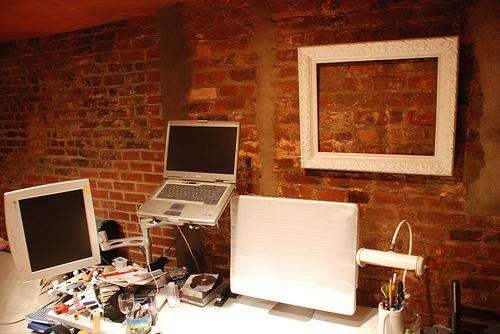Question: how many computer screens are in the picture?
Choices:
A. Four.
B. Two.
C. Five.
D. Three.
Answer with the letter. Answer: D Question: what is visible in the picture frame?
Choices:
A. The photo.
B. The light reflected.
C. The wall.
D. People.
Answer with the letter. Answer: C Question: where is the laptop?
Choices:
A. Between the two screens.
B. On the bed.
C. On the sofa.
D. On her lap.
Answer with the letter. Answer: A Question: what material is the wall made of?
Choices:
A. Dry wall plaster.
B. Bricks.
C. Stucco.
D. Wood.
Answer with the letter. Answer: B Question: what shape is the picture frame?
Choices:
A. Circle.
B. Square.
C. Triangle.
D. Rectangle.
Answer with the letter. Answer: D Question: what shape is the desk light above the pencil cup?
Choices:
A. Round.
B. Square.
C. Oval.
D. Cylinder.
Answer with the letter. Answer: D 